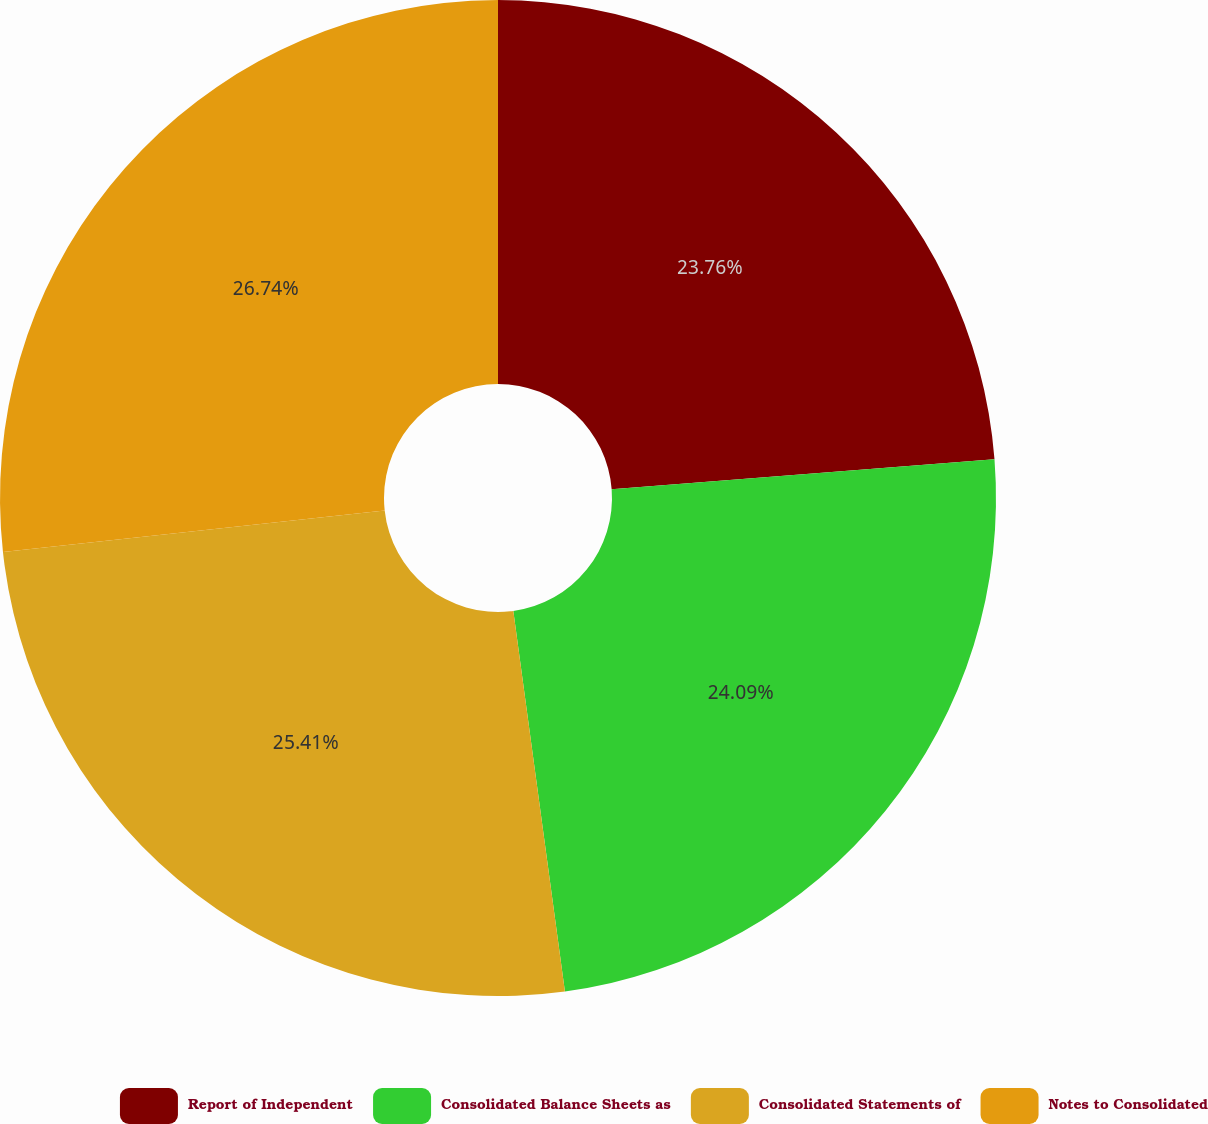Convert chart to OTSL. <chart><loc_0><loc_0><loc_500><loc_500><pie_chart><fcel>Report of Independent<fcel>Consolidated Balance Sheets as<fcel>Consolidated Statements of<fcel>Notes to Consolidated<nl><fcel>23.76%<fcel>24.09%<fcel>25.41%<fcel>26.73%<nl></chart> 